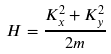Convert formula to latex. <formula><loc_0><loc_0><loc_500><loc_500>H = \frac { K _ { x } ^ { 2 } + K _ { y } ^ { 2 } } { 2 m }</formula> 